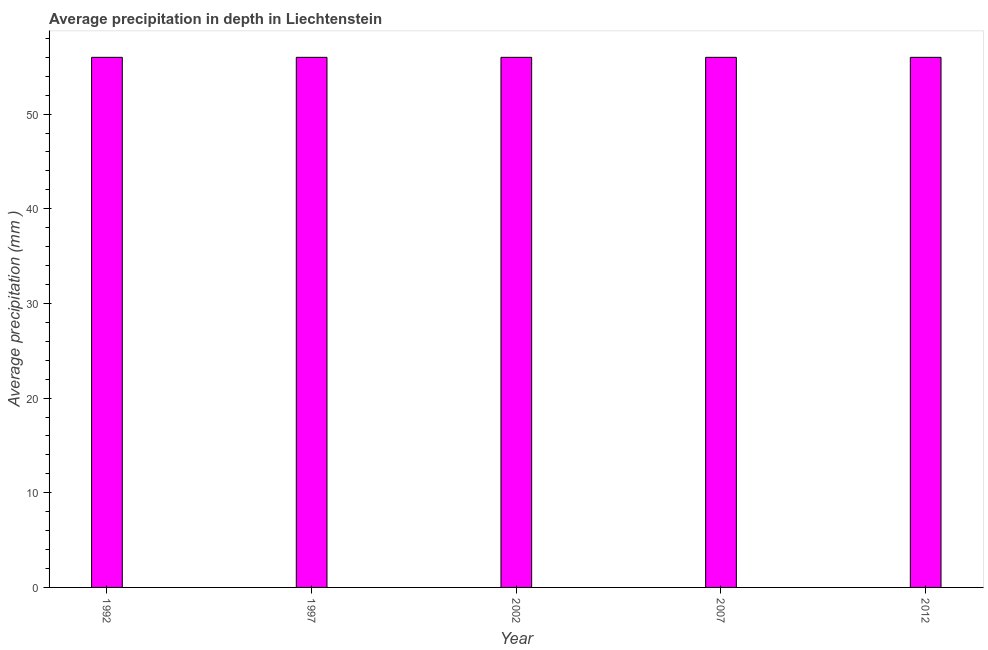Does the graph contain any zero values?
Offer a terse response. No. Does the graph contain grids?
Offer a terse response. No. What is the title of the graph?
Your answer should be very brief. Average precipitation in depth in Liechtenstein. What is the label or title of the Y-axis?
Provide a short and direct response. Average precipitation (mm ). Across all years, what is the minimum average precipitation in depth?
Provide a succinct answer. 56. What is the sum of the average precipitation in depth?
Your response must be concise. 280. What is the difference between the average precipitation in depth in 1992 and 1997?
Offer a very short reply. 0. What is the median average precipitation in depth?
Provide a succinct answer. 56. Do a majority of the years between 2002 and 1997 (inclusive) have average precipitation in depth greater than 48 mm?
Offer a terse response. No. What is the ratio of the average precipitation in depth in 1997 to that in 2002?
Your answer should be compact. 1. Is the average precipitation in depth in 2002 less than that in 2007?
Offer a terse response. No. Is the difference between the average precipitation in depth in 1992 and 2002 greater than the difference between any two years?
Offer a terse response. Yes. Are all the bars in the graph horizontal?
Offer a terse response. No. What is the Average precipitation (mm ) of 2002?
Your answer should be compact. 56. What is the Average precipitation (mm ) in 2007?
Give a very brief answer. 56. What is the difference between the Average precipitation (mm ) in 1992 and 2002?
Provide a succinct answer. 0. What is the difference between the Average precipitation (mm ) in 1997 and 2012?
Your response must be concise. 0. What is the difference between the Average precipitation (mm ) in 2007 and 2012?
Provide a short and direct response. 0. What is the ratio of the Average precipitation (mm ) in 1992 to that in 1997?
Keep it short and to the point. 1. What is the ratio of the Average precipitation (mm ) in 1992 to that in 2007?
Your answer should be compact. 1. What is the ratio of the Average precipitation (mm ) in 1997 to that in 2007?
Provide a short and direct response. 1. What is the ratio of the Average precipitation (mm ) in 2002 to that in 2012?
Keep it short and to the point. 1. 